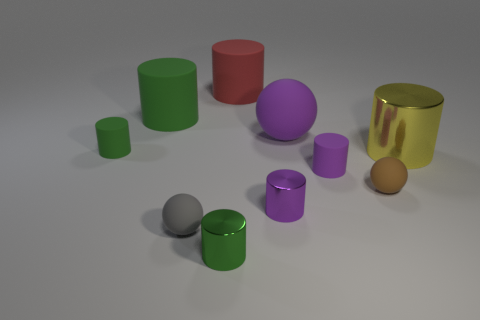Subtract all brown cubes. How many green cylinders are left? 3 Subtract 1 cylinders. How many cylinders are left? 6 Subtract all red cylinders. How many cylinders are left? 6 Subtract all small purple cylinders. How many cylinders are left? 5 Subtract all red cylinders. Subtract all cyan spheres. How many cylinders are left? 6 Subtract all spheres. How many objects are left? 7 Subtract all yellow metal cylinders. Subtract all tiny green shiny cylinders. How many objects are left? 8 Add 6 tiny gray balls. How many tiny gray balls are left? 7 Add 9 purple cubes. How many purple cubes exist? 9 Subtract 0 blue cubes. How many objects are left? 10 